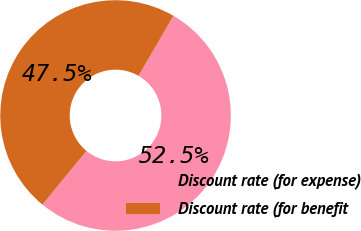Convert chart. <chart><loc_0><loc_0><loc_500><loc_500><pie_chart><fcel>Discount rate (for expense)<fcel>Discount rate (for benefit<nl><fcel>52.55%<fcel>47.45%<nl></chart> 